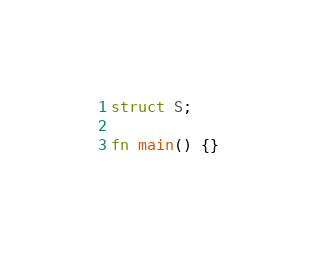<code> <loc_0><loc_0><loc_500><loc_500><_Rust_>struct S;

fn main() {}
</code> 